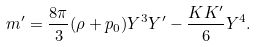Convert formula to latex. <formula><loc_0><loc_0><loc_500><loc_500>m ^ { \prime } = \frac { 8 \pi } { 3 } ( \rho + p _ { 0 } ) Y ^ { 3 } Y ^ { \prime } - \frac { K K ^ { \prime } } { 6 } Y ^ { 4 } .</formula> 